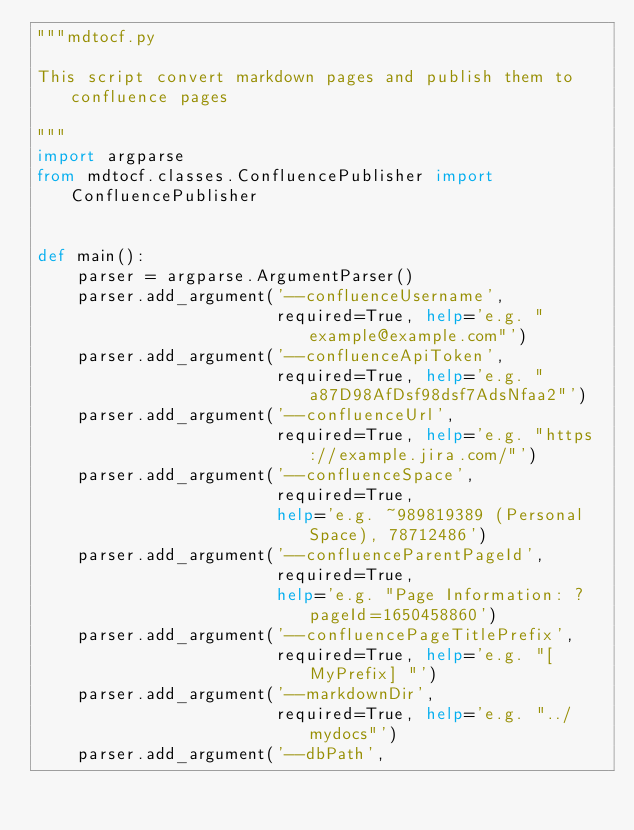<code> <loc_0><loc_0><loc_500><loc_500><_Python_>"""mdtocf.py

This script convert markdown pages and publish them to confluence pages

"""
import argparse
from mdtocf.classes.ConfluencePublisher import ConfluencePublisher


def main():
    parser = argparse.ArgumentParser()
    parser.add_argument('--confluenceUsername',
                        required=True, help='e.g. "example@example.com"')
    parser.add_argument('--confluenceApiToken',
                        required=True, help='e.g. "a87D98AfDsf98dsf7AdsNfaa2"')
    parser.add_argument('--confluenceUrl',
                        required=True, help='e.g. "https://example.jira.com/"')
    parser.add_argument('--confluenceSpace',
                        required=True,
                        help='e.g. ~989819389 (Personal Space), 78712486')
    parser.add_argument('--confluenceParentPageId',
                        required=True,
                        help='e.g. "Page Information: ?pageId=1650458860')
    parser.add_argument('--confluencePageTitlePrefix',
                        required=True, help='e.g. "[MyPrefix] "')
    parser.add_argument('--markdownDir',
                        required=True, help='e.g. "../mydocs"')
    parser.add_argument('--dbPath',</code> 